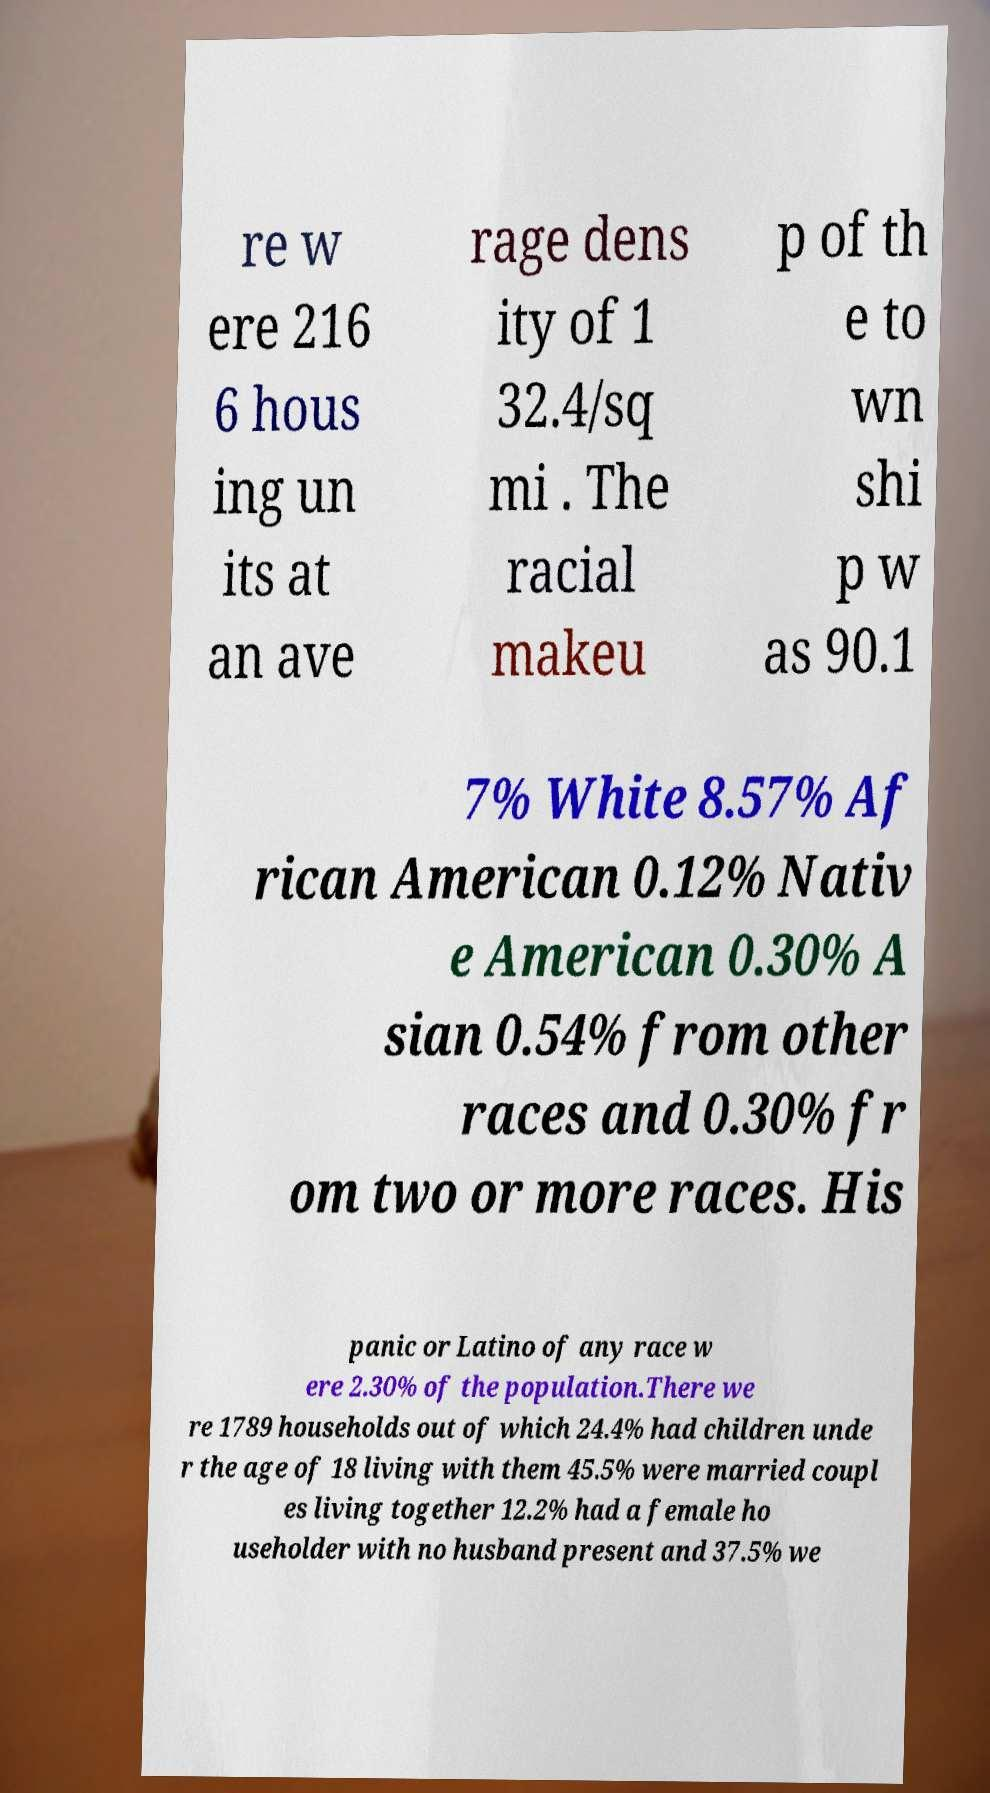Can you accurately transcribe the text from the provided image for me? re w ere 216 6 hous ing un its at an ave rage dens ity of 1 32.4/sq mi . The racial makeu p of th e to wn shi p w as 90.1 7% White 8.57% Af rican American 0.12% Nativ e American 0.30% A sian 0.54% from other races and 0.30% fr om two or more races. His panic or Latino of any race w ere 2.30% of the population.There we re 1789 households out of which 24.4% had children unde r the age of 18 living with them 45.5% were married coupl es living together 12.2% had a female ho useholder with no husband present and 37.5% we 